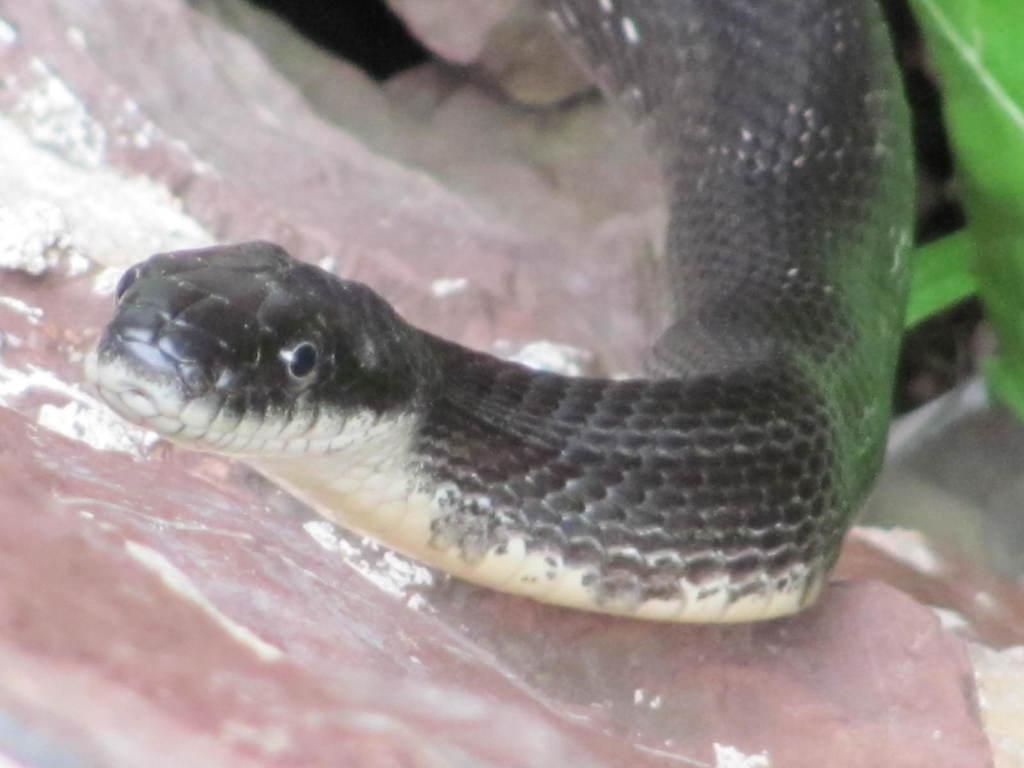What type of animal is in the image? There is a black snake in the image. What can be seen in the background of the image? There is a rock in the background of the image. What type of fuel is the snake using to move in the image? Snakes do not use fuel to move; they rely on their muscles and skeletal structure to propel themselves. 